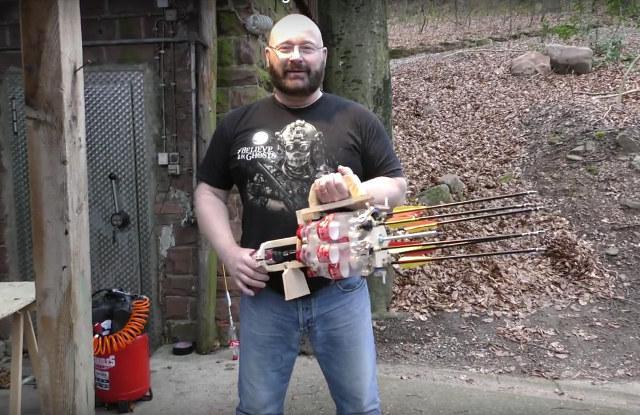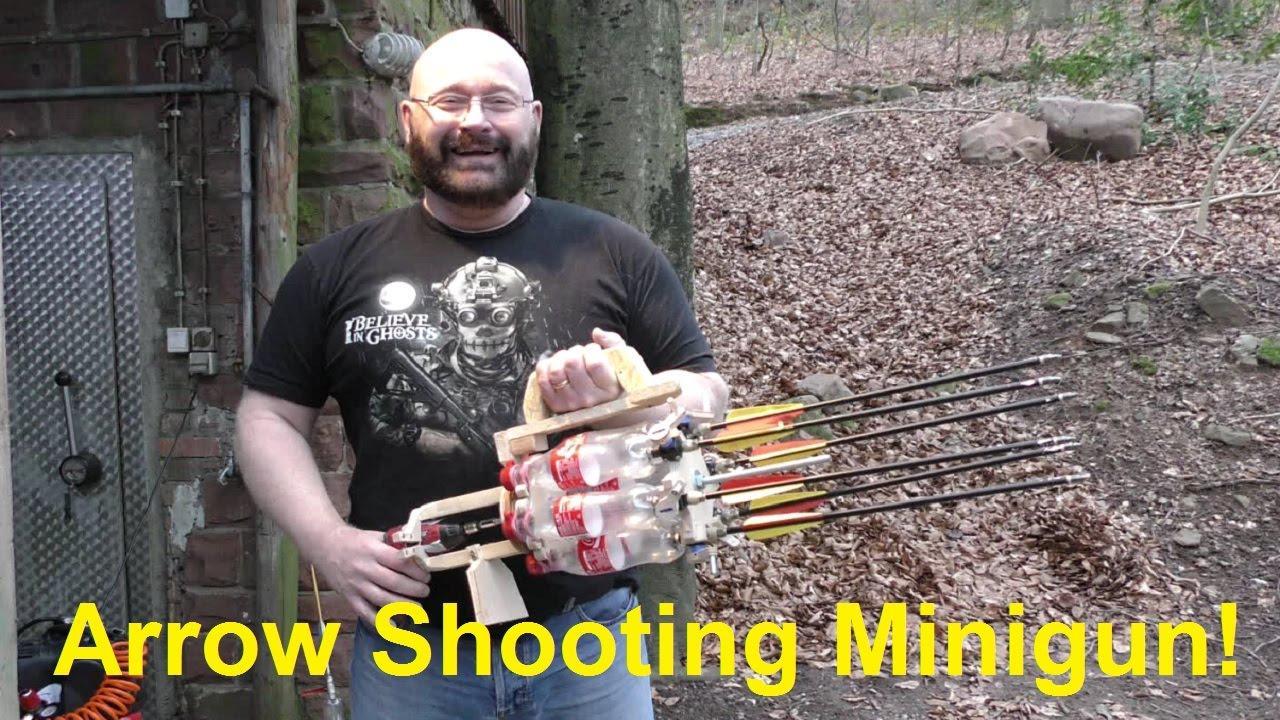The first image is the image on the left, the second image is the image on the right. Given the left and right images, does the statement "One of the images contains a Pepsi product." hold true? Answer yes or no. No. 